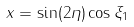<formula> <loc_0><loc_0><loc_500><loc_500>x = \sin ( 2 \eta ) \cos \xi _ { 1 }</formula> 